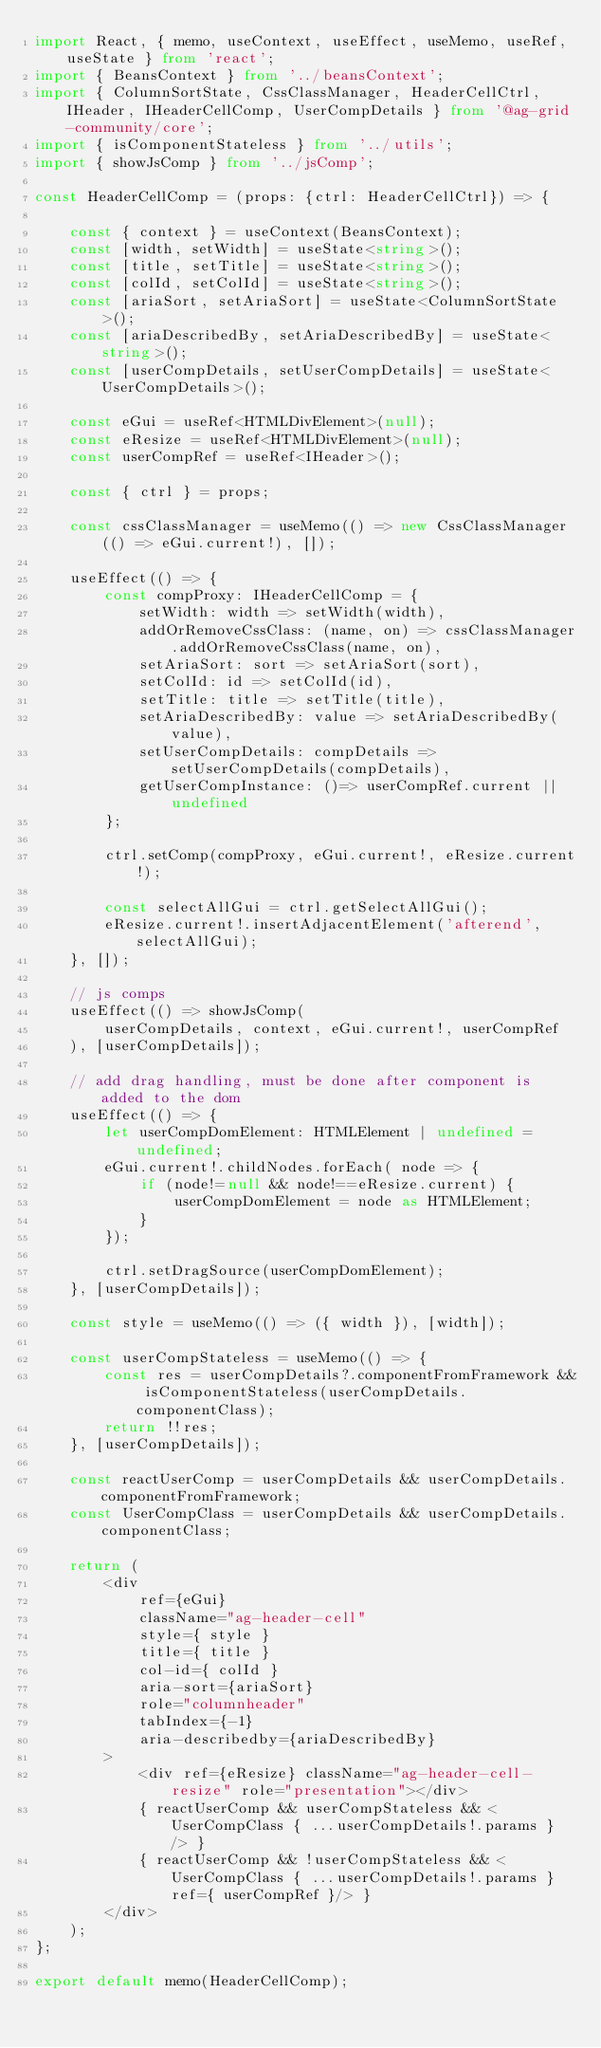Convert code to text. <code><loc_0><loc_0><loc_500><loc_500><_TypeScript_>import React, { memo, useContext, useEffect, useMemo, useRef, useState } from 'react';
import { BeansContext } from '../beansContext';
import { ColumnSortState, CssClassManager, HeaderCellCtrl, IHeader, IHeaderCellComp, UserCompDetails } from '@ag-grid-community/core';
import { isComponentStateless } from '../utils';
import { showJsComp } from '../jsComp';

const HeaderCellComp = (props: {ctrl: HeaderCellCtrl}) => {

    const { context } = useContext(BeansContext);
    const [width, setWidth] = useState<string>();
    const [title, setTitle] = useState<string>();
    const [colId, setColId] = useState<string>();
    const [ariaSort, setAriaSort] = useState<ColumnSortState>();
    const [ariaDescribedBy, setAriaDescribedBy] = useState<string>();
    const [userCompDetails, setUserCompDetails] = useState<UserCompDetails>();

    const eGui = useRef<HTMLDivElement>(null);
    const eResize = useRef<HTMLDivElement>(null);
    const userCompRef = useRef<IHeader>();

    const { ctrl } = props;

    const cssClassManager = useMemo(() => new CssClassManager(() => eGui.current!), []);

    useEffect(() => {
        const compProxy: IHeaderCellComp = {
            setWidth: width => setWidth(width),
            addOrRemoveCssClass: (name, on) => cssClassManager.addOrRemoveCssClass(name, on),
            setAriaSort: sort => setAriaSort(sort),
            setColId: id => setColId(id),
            setTitle: title => setTitle(title),
            setAriaDescribedBy: value => setAriaDescribedBy(value),
            setUserCompDetails: compDetails => setUserCompDetails(compDetails),
            getUserCompInstance: ()=> userCompRef.current || undefined
        };

        ctrl.setComp(compProxy, eGui.current!, eResize.current!);

        const selectAllGui = ctrl.getSelectAllGui();
        eResize.current!.insertAdjacentElement('afterend', selectAllGui);
    }, []);

    // js comps
    useEffect(() => showJsComp(
        userCompDetails, context, eGui.current!, userCompRef
    ), [userCompDetails]);

    // add drag handling, must be done after component is added to the dom
    useEffect(() => {
        let userCompDomElement: HTMLElement | undefined = undefined;
        eGui.current!.childNodes.forEach( node => {
            if (node!=null && node!==eResize.current) {
                userCompDomElement = node as HTMLElement;
            }
        });

        ctrl.setDragSource(userCompDomElement);
    }, [userCompDetails]);

    const style = useMemo(() => ({ width }), [width]);

    const userCompStateless = useMemo(() => {
        const res = userCompDetails?.componentFromFramework && isComponentStateless(userCompDetails.componentClass);
        return !!res;
    }, [userCompDetails]);

    const reactUserComp = userCompDetails && userCompDetails.componentFromFramework;
    const UserCompClass = userCompDetails && userCompDetails.componentClass;

    return (
        <div
            ref={eGui}
            className="ag-header-cell"
            style={ style }
            title={ title }
            col-id={ colId }
            aria-sort={ariaSort}
            role="columnheader"
            tabIndex={-1}
            aria-describedby={ariaDescribedBy}
        >
            <div ref={eResize} className="ag-header-cell-resize" role="presentation"></div>
            { reactUserComp && userCompStateless && <UserCompClass { ...userCompDetails!.params } /> }
            { reactUserComp && !userCompStateless && <UserCompClass { ...userCompDetails!.params } ref={ userCompRef }/> }
        </div>
    );
};

export default memo(HeaderCellComp);
</code> 